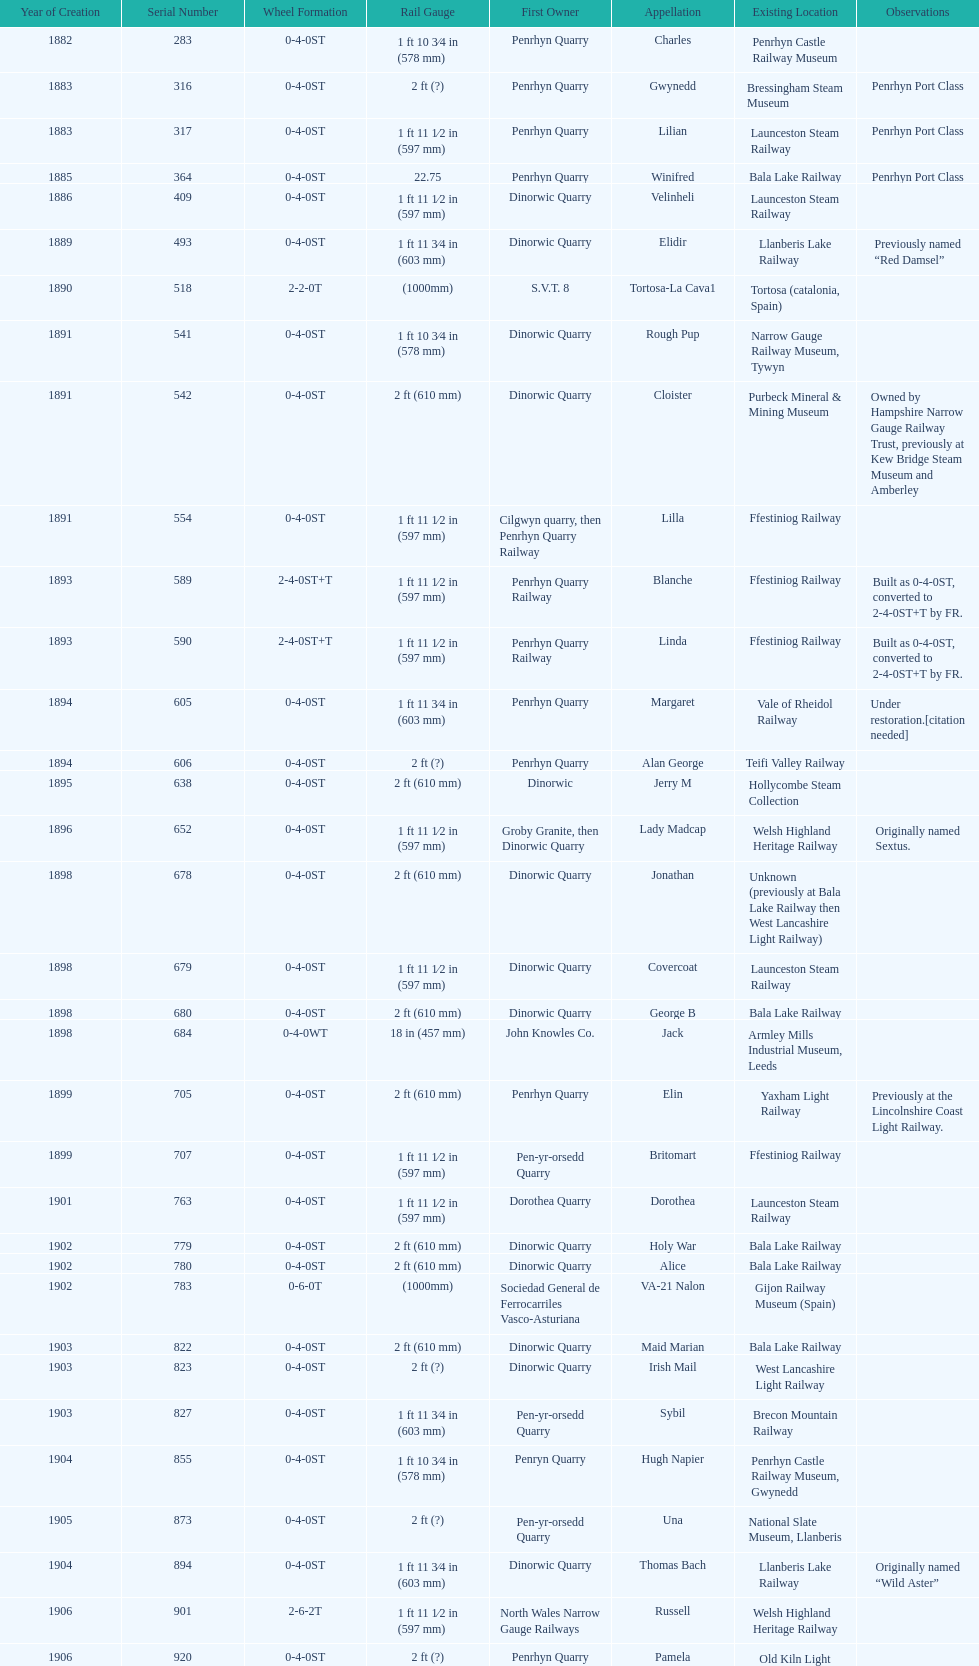Aside from 316, what was the other works number used in 1883? 317. 